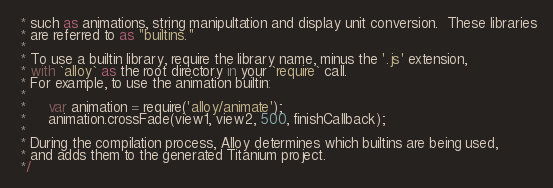Convert code to text. <code><loc_0><loc_0><loc_500><loc_500><_JavaScript_> * such as animations, string manipultation and display unit conversion.  These libraries
 * are referred to as "builtins."
 *
 * To use a builtin library, require the library name, minus the '.js' extension,
 * with `alloy` as the root directory in your `require` call.
 * For example, to use the animation builtin:
 *
 *     var animation = require('alloy/animate');
 *     animation.crossFade(view1, view2, 500, finishCallback);
 *
 * During the compilation process, Alloy determines which builtins are being used,
 * and adds them to the generated Titanium project.
 */
</code> 